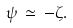Convert formula to latex. <formula><loc_0><loc_0><loc_500><loc_500>\psi \, \simeq \, - \zeta .</formula> 